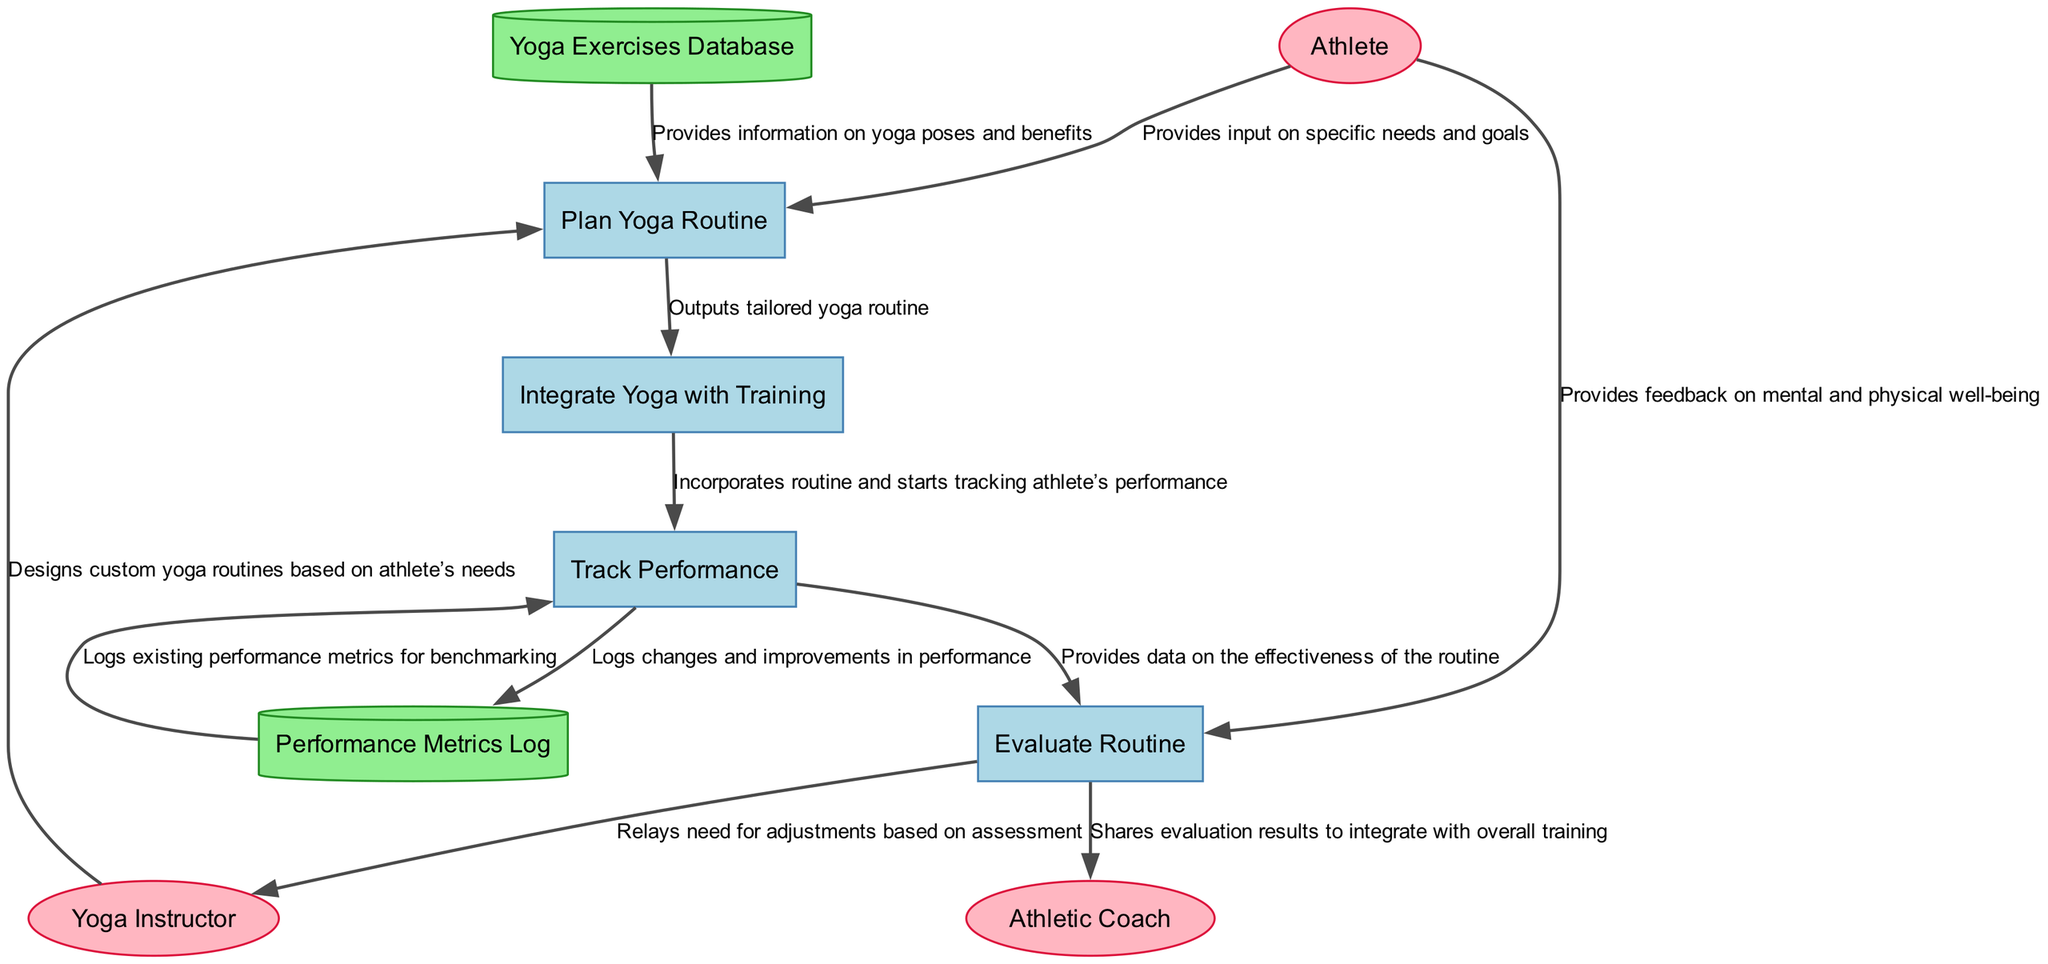What are the external entities involved in the diagram? The diagram features three external entities: the Athlete, Yoga Instructor, and Athletic Coach. Each of these entities has a specific role in the integration of yoga routines into the athletic training regimen.
Answer: Athlete, Yoga Instructor, Athletic Coach What is the first process in the diagram? The first process in the diagram is "Plan Yoga Routine." This process is responsible for designing a yoga routine that is tailored to the athlete's specific needs.
Answer: Plan Yoga Routine How many processes are represented in the diagram? There are four processes shown in the diagram: Plan Yoga Routine, Integrate Yoga with Training, Track Performance, and Evaluate Routine.
Answer: Four Which data store logs changes in performance after integrating yoga? The data store that logs changes in performance is called "Performance Metrics Log." It records the performance metrics before and after integrating yoga into the training regimen.
Answer: Performance Metrics Log How does the "Track Performance" process interact with the "Evaluate Routine" process? The "Track Performance" process provides data on the effectiveness of the yoga routine to the "Evaluate Routine" process. This interaction helps assess how well the integrated yoga practices are working for the athlete.
Answer: By providing data What is the purpose of the "Evaluate Routine" process? The purpose of the "Evaluate Routine" process is to conduct periodic assessments of the effectiveness of the yoga routine and make necessary adjustments based on feedback and performance data.
Answer: Periodic assessments What information does the Yoga Instructor provide to the "Plan Yoga Routine" process? The Yoga Instructor provides custom-designed yoga routines based on the athlete's needs and goals. This input is crucial for creating a personalized training plan.
Answer: Custom yoga routines What action does the Athlete take in the "Evaluate Routine" process? In the "Evaluate Routine" process, the Athlete provides feedback regarding their mental and physical well-being, which is essential for the adjustments made to the yoga routine.
Answer: Provides feedback Which process directly outputs a tailored yoga routine? The process that directly outputs a tailored yoga routine is "Plan Yoga Routine." This process synthesizes information from the athlete, yoga instructor, and yoga exercises database to create a specific routine.
Answer: Plan Yoga Routine 